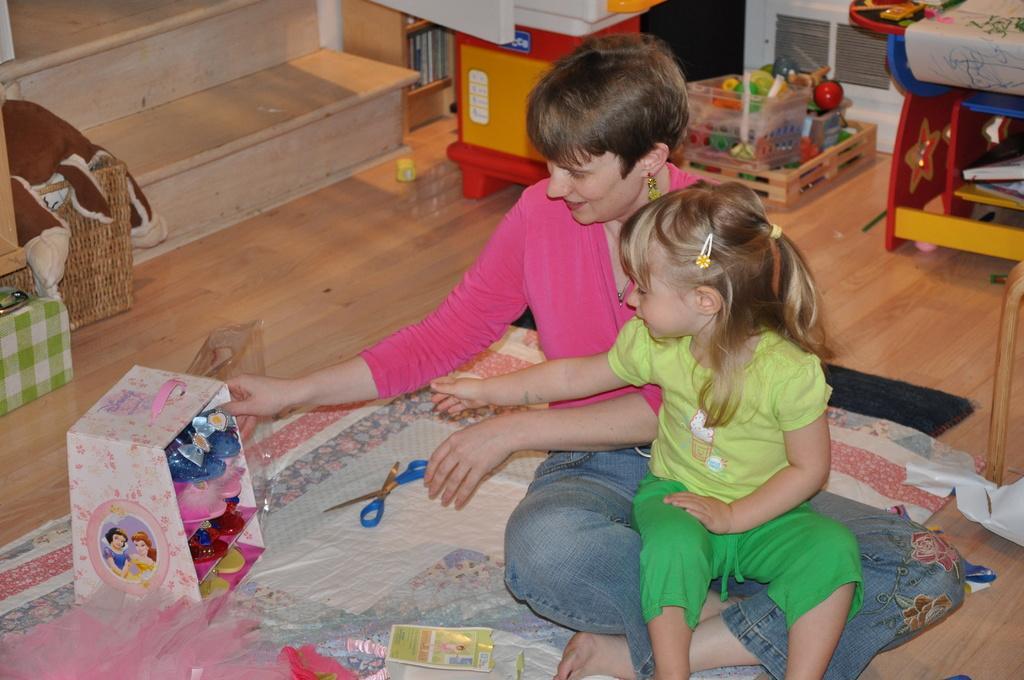Could you give a brief overview of what you see in this image? In this picture we can see woman sitting on bed sheet and on her girl is sitting and beside to them there is scissor, toy rack, paper and in background we can see basket, steps, toys. 